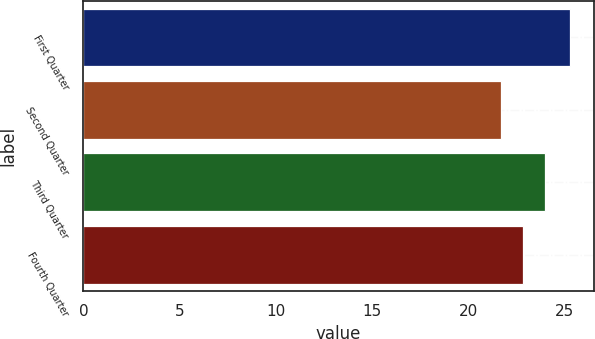<chart> <loc_0><loc_0><loc_500><loc_500><bar_chart><fcel>First Quarter<fcel>Second Quarter<fcel>Third Quarter<fcel>Fourth Quarter<nl><fcel>25.25<fcel>21.68<fcel>24<fcel>22.82<nl></chart> 